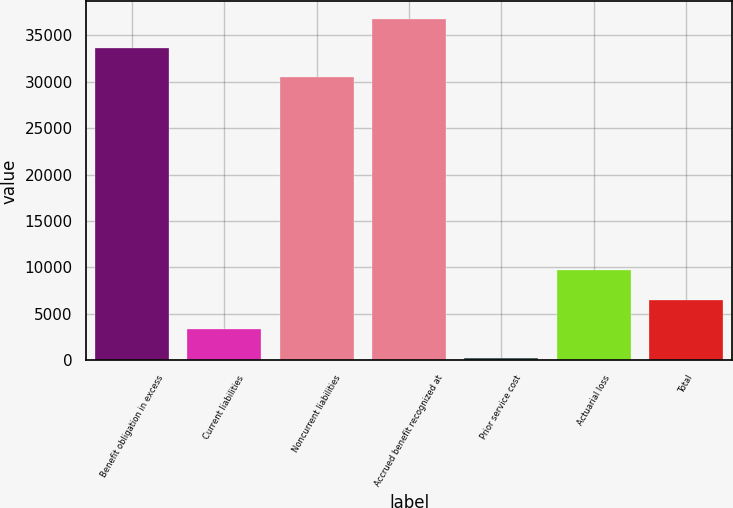Convert chart. <chart><loc_0><loc_0><loc_500><loc_500><bar_chart><fcel>Benefit obligation in excess<fcel>Current liabilities<fcel>Noncurrent liabilities<fcel>Accrued benefit recognized at<fcel>Prior service cost<fcel>Actuarial loss<fcel>Total<nl><fcel>33632<fcel>3375<fcel>30473<fcel>36791<fcel>216<fcel>9693<fcel>6534<nl></chart> 